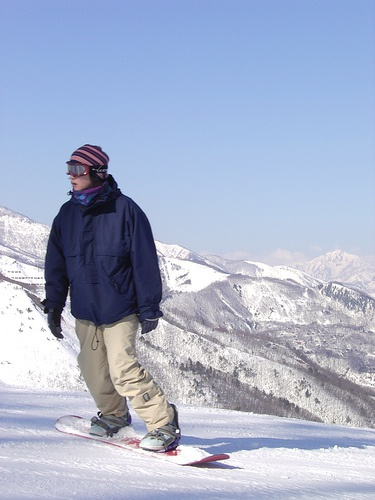Describe the objects in this image and their specific colors. I can see people in darkgray, navy, black, and gray tones and snowboard in darkgray, white, and brown tones in this image. 